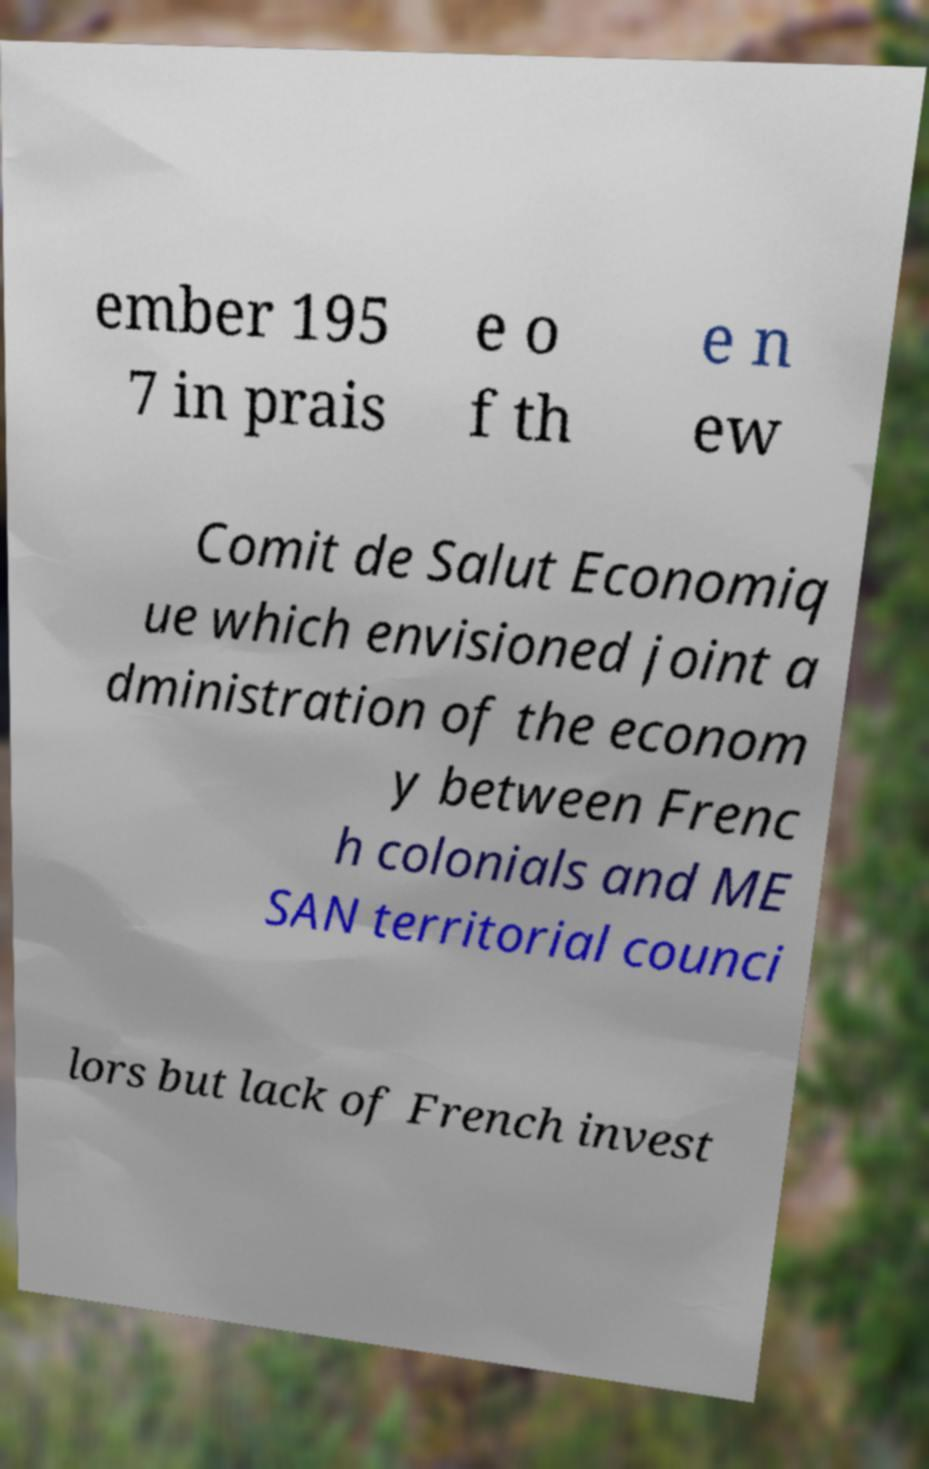Can you read and provide the text displayed in the image?This photo seems to have some interesting text. Can you extract and type it out for me? ember 195 7 in prais e o f th e n ew Comit de Salut Economiq ue which envisioned joint a dministration of the econom y between Frenc h colonials and ME SAN territorial counci lors but lack of French invest 